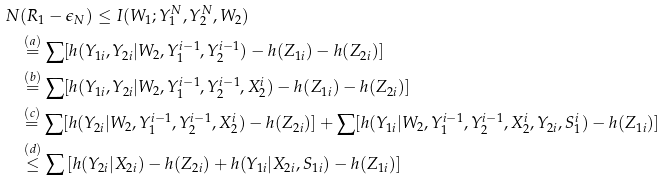Convert formula to latex. <formula><loc_0><loc_0><loc_500><loc_500>N & ( R _ { 1 } - \epsilon _ { N } ) \leq I ( W _ { 1 } ; Y _ { 1 } ^ { N } , Y _ { 2 } ^ { N } , W _ { 2 } ) \\ & \overset { ( a ) } = \sum [ h ( Y _ { 1 i } , Y _ { 2 i } | W _ { 2 } , Y _ { 1 } ^ { i - 1 } , Y _ { 2 } ^ { i - 1 } ) - h ( Z _ { 1 i } ) - h ( Z _ { 2 i } ) ] \\ & \overset { ( b ) } { = } \sum [ h ( Y _ { 1 i } , Y _ { 2 i } | W _ { 2 } , Y _ { 1 } ^ { i - 1 } , Y _ { 2 } ^ { i - 1 } , X _ { 2 } ^ { i } ) - h ( Z _ { 1 i } ) - h ( Z _ { 2 i } ) ] \\ & \overset { ( c ) } { = } \sum [ h ( Y _ { 2 i } | W _ { 2 } , Y _ { 1 } ^ { i - 1 } , Y _ { 2 } ^ { i - 1 } , X _ { 2 } ^ { i } ) - h ( Z _ { 2 i } ) ] + \sum [ h ( Y _ { 1 i } | W _ { 2 } , Y _ { 1 } ^ { i - 1 } , Y _ { 2 } ^ { i - 1 } , X _ { 2 } ^ { i } , Y _ { 2 i } , S _ { 1 } ^ { i } ) - h ( Z _ { 1 i } ) ] \\ & \overset { ( d ) } { \leq } \sum \left [ h ( Y _ { 2 i } | X _ { 2 i } ) - h ( Z _ { 2 i } ) + h ( Y _ { 1 i } | X _ { 2 i } , S _ { 1 i } ) - h ( Z _ { 1 i } ) \right ]</formula> 